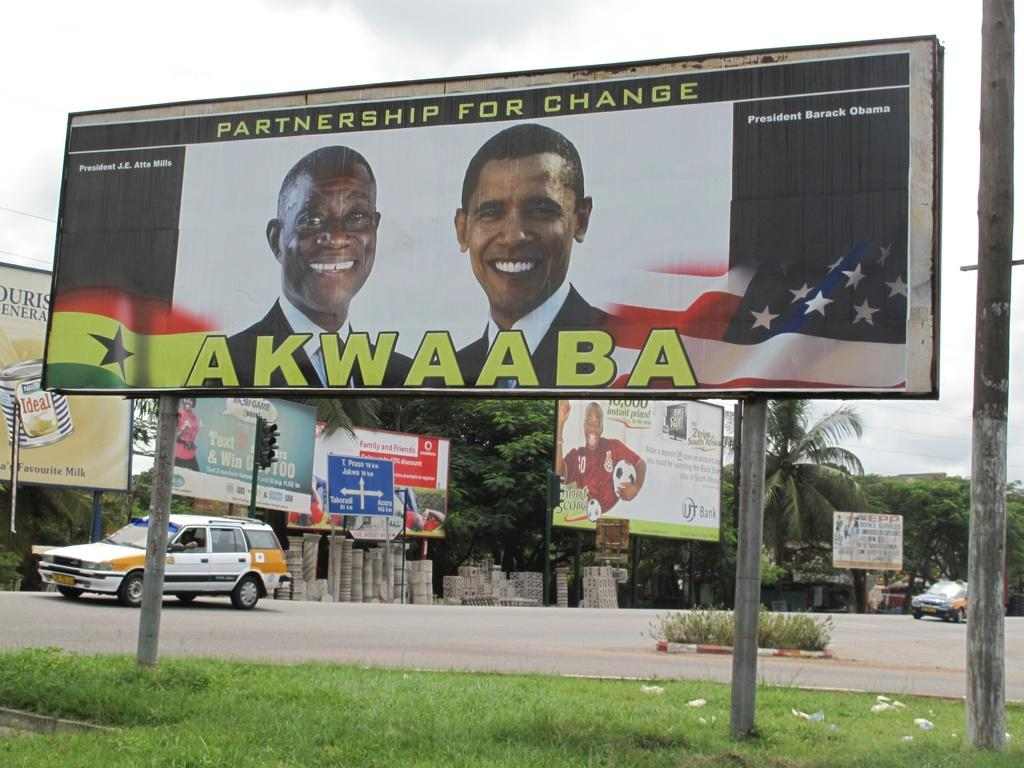<image>
Write a terse but informative summary of the picture. A sign that says Partnership for change Akwaaba. 